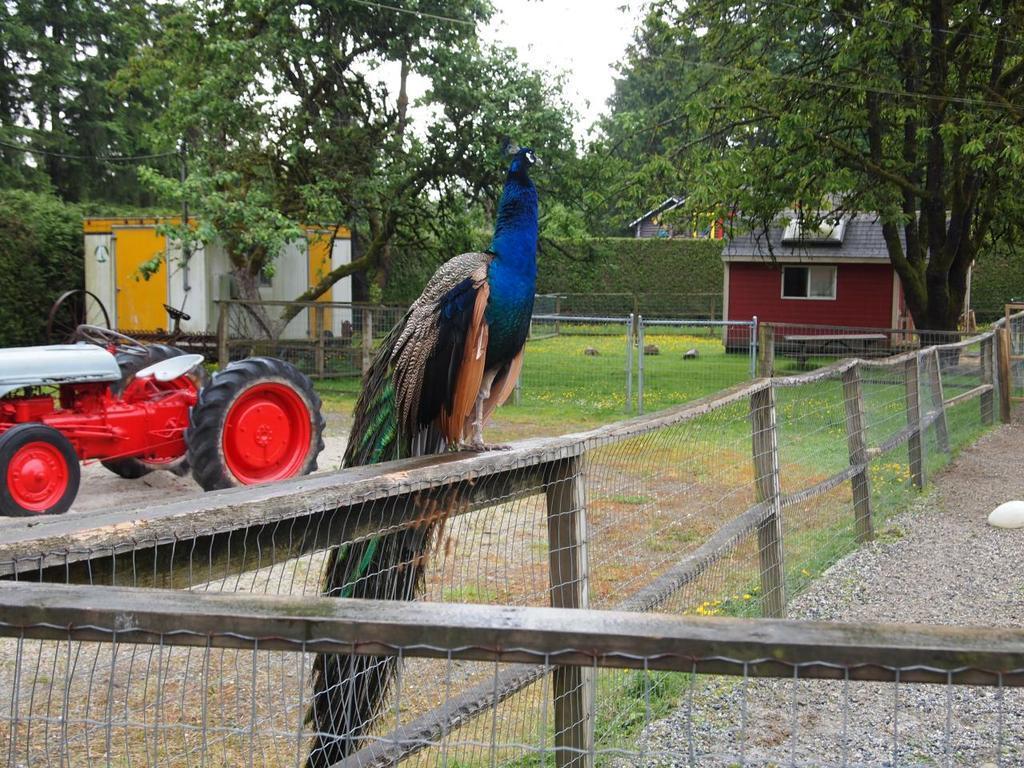Could you give a brief overview of what you see in this image? In this image we can see a peacock standing on the wooden fence. In the background we can see trees, sky, buildings, motor vehicle on the ground and a generator. 